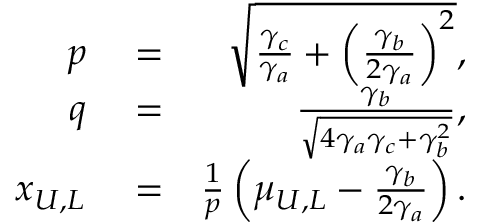Convert formula to latex. <formula><loc_0><loc_0><loc_500><loc_500>\begin{array} { r l r } { p } & = } & { \sqrt { \frac { \gamma _ { c } } { \gamma _ { a } } + \left ( \frac { \gamma _ { b } } { 2 \gamma _ { a } } \right ) ^ { 2 } } , } \\ { q } & = } & { \frac { \gamma _ { b } } { \sqrt { 4 \gamma _ { a } \gamma _ { c } + \gamma _ { b } ^ { 2 } } } , } \\ { x _ { U , L } } & = } & { \frac { 1 } { p } \left ( \mu _ { U , L } - \frac { \gamma _ { b } } { 2 \gamma _ { a } } \right ) . } \end{array}</formula> 